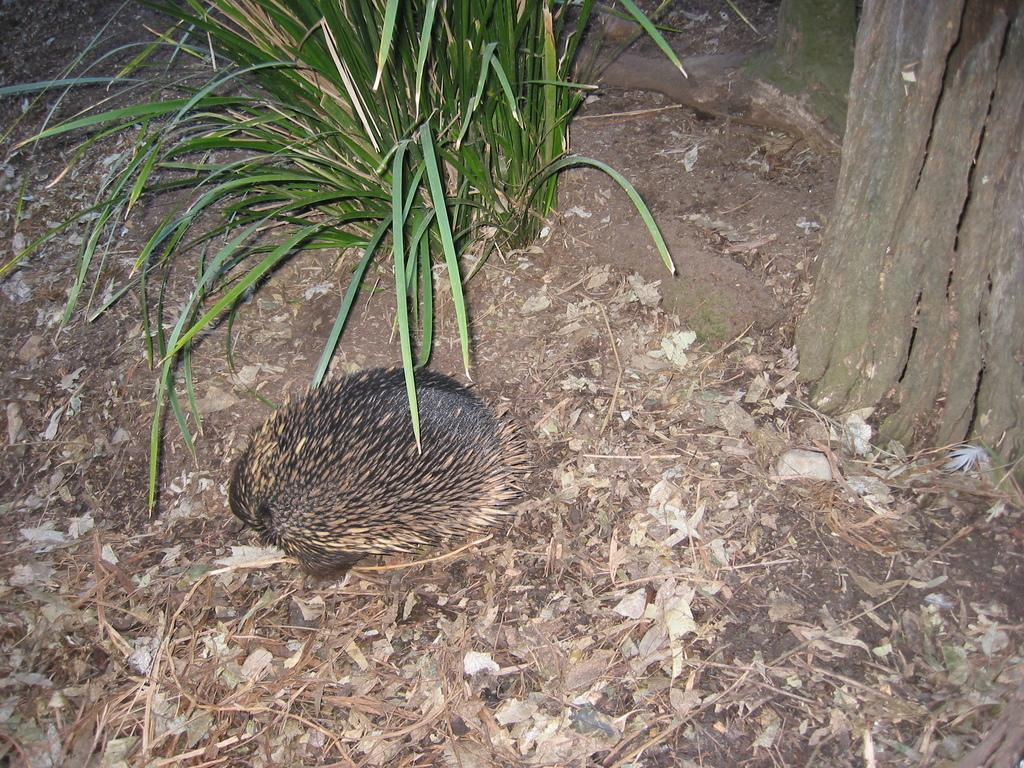What type of creature is in the image? There is an animal in the image. Where is the animal located? The animal is on the ground. What else can be seen in the image besides the animal? There are plants in the image. How are the plants positioned in relation to the animal? The plants are beside the animal. What is the animal's reaction to the disgusting smell in the image? There is no mention of a disgusting smell in the image, so it cannot be determined how the animal would react. 